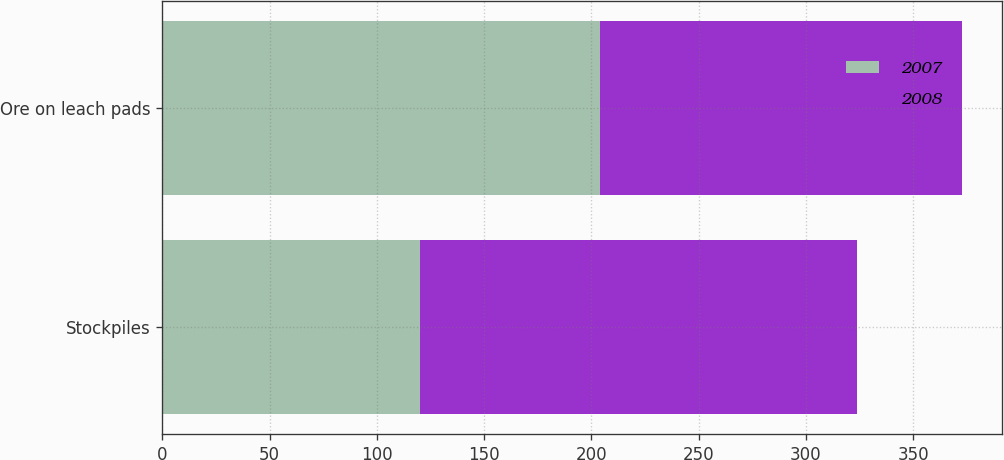Convert chart. <chart><loc_0><loc_0><loc_500><loc_500><stacked_bar_chart><ecel><fcel>Stockpiles<fcel>Ore on leach pads<nl><fcel>2007<fcel>120<fcel>204<nl><fcel>2008<fcel>204<fcel>169<nl></chart> 